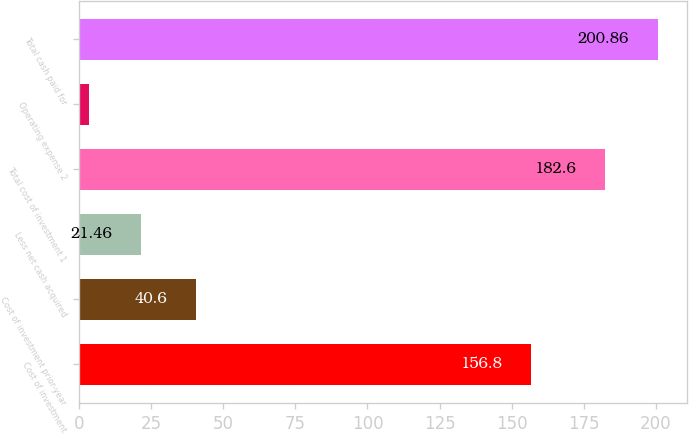Convert chart. <chart><loc_0><loc_0><loc_500><loc_500><bar_chart><fcel>Cost of investment<fcel>Cost of investment prior-year<fcel>Less net cash acquired<fcel>Total cost of investment 1<fcel>Operating expense 2<fcel>Total cash paid for<nl><fcel>156.8<fcel>40.6<fcel>21.46<fcel>182.6<fcel>3.2<fcel>200.86<nl></chart> 